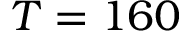<formula> <loc_0><loc_0><loc_500><loc_500>T = 1 6 0</formula> 